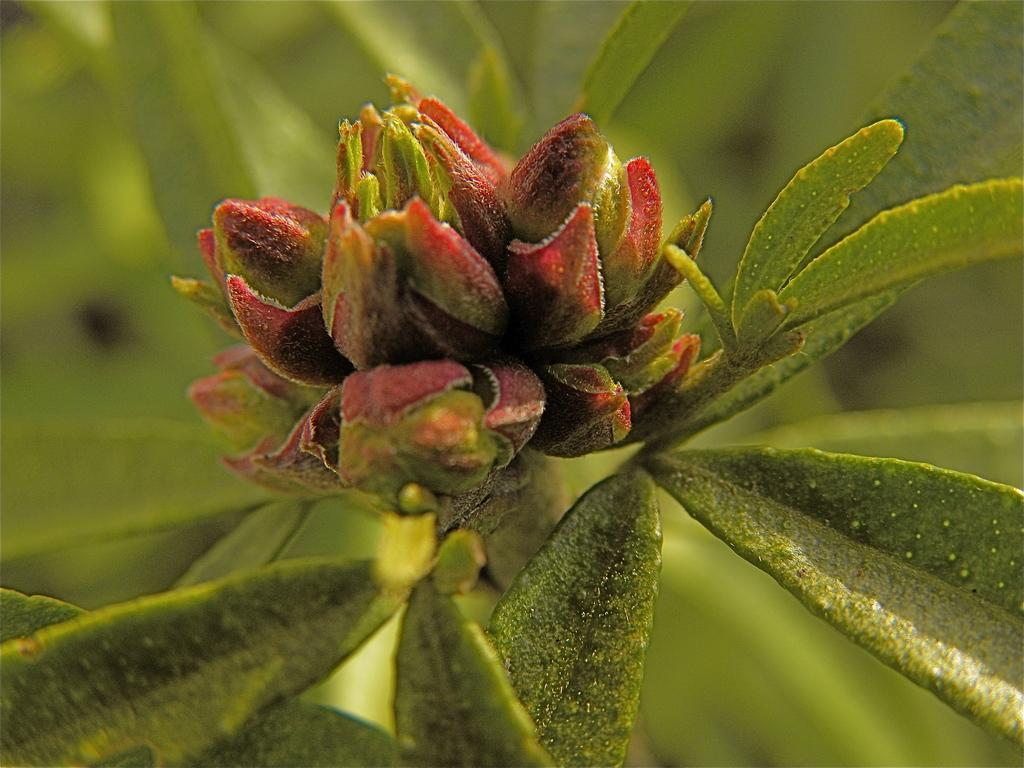What is the main subject of the image? There is a flower in the image. What else can be seen in the image besides the flower? There are leaves in the image. Can you describe the background of the image? The background of the image is blurred. How many fingers can be seen touching the flower in the image? There are no fingers or hands visible in the image, as it only features a flower and leaves. 